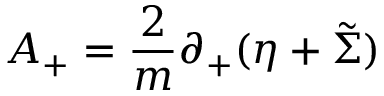Convert formula to latex. <formula><loc_0><loc_0><loc_500><loc_500>A _ { + } = { \frac { 2 } { m } } \partial _ { + } ( \eta + \tilde { \Sigma } )</formula> 